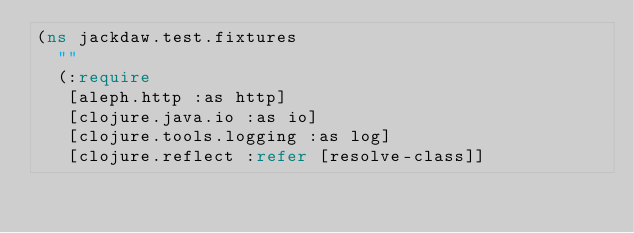Convert code to text. <code><loc_0><loc_0><loc_500><loc_500><_Clojure_>(ns jackdaw.test.fixtures
  ""
  (:require
   [aleph.http :as http]
   [clojure.java.io :as io]
   [clojure.tools.logging :as log]
   [clojure.reflect :refer [resolve-class]]</code> 